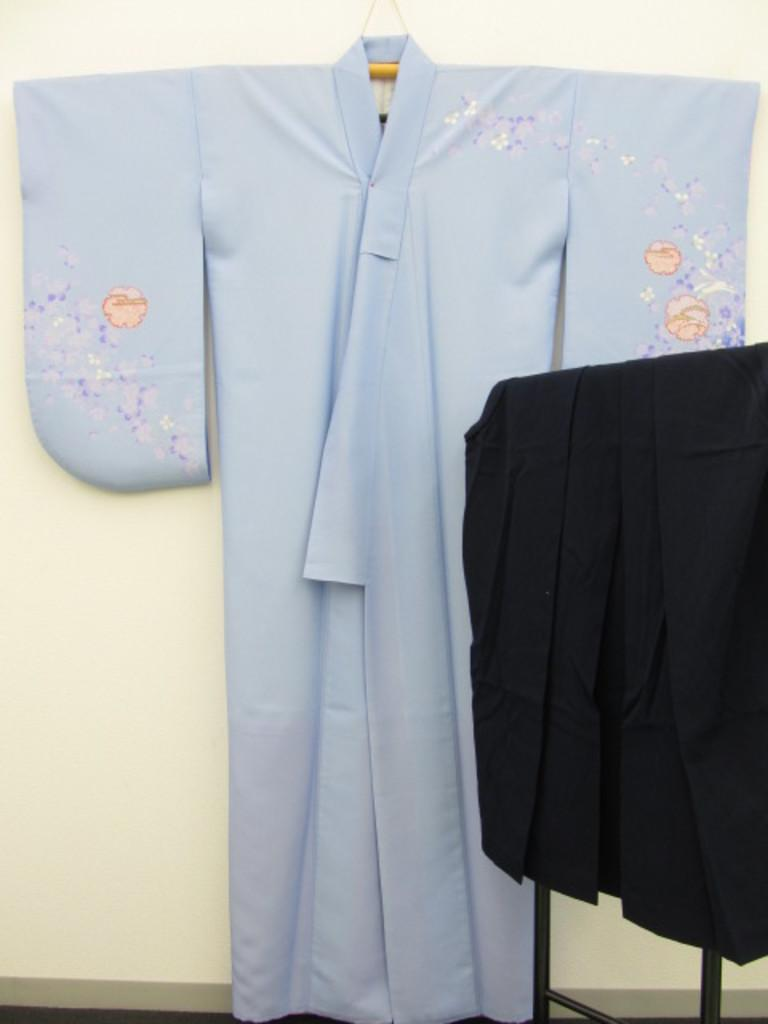What can be seen in the image that serves as a support for the dress? There is a holder with a dress hanged on it in the image. What is the color of the object with the cloth on it? The object has a black color, and there is a black color cloth on it. What is the primary architectural feature visible in the image? There is a wall in the image. Can you see any drugs on the wall in the image? There is no mention of drugs in the image, and no drugs are visible. Is there a toad sitting on the black color object in the image? There is no toad present in the image. 